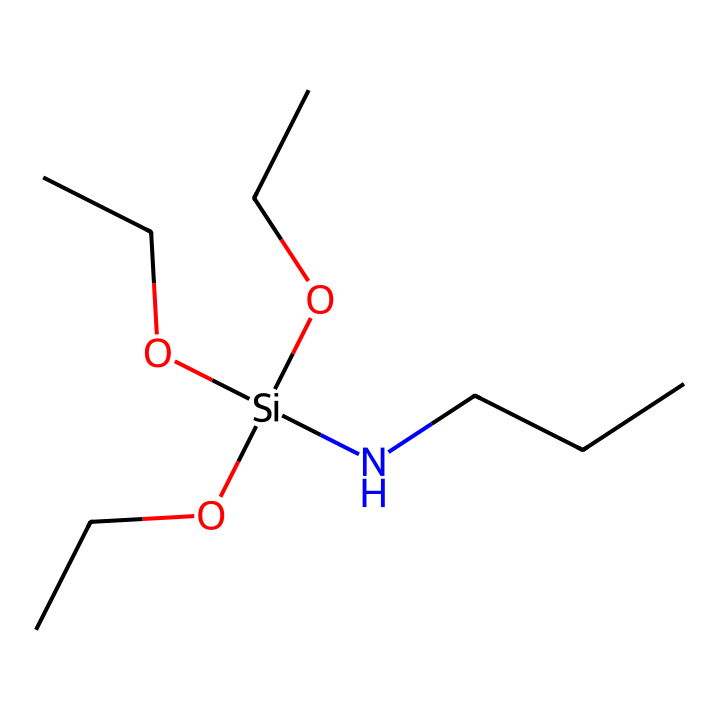What is the molecular formula of the represented chemical? The chemical structure shows three ethyl groups (OCC), one nitrogen atom (N), and one silicon atom (Si), along with three oxygen atoms (O). Counting all these components gives the molecular formula C9H21N1O3Si1.
Answer: C9H21N1O3Si1 How many ethyl groups are present in the structure? The structure features three OCC groups attached to the silicon atom. Each OCC stands for an ethyl group, hence there are three of them.
Answer: 3 What type of bonding is primarily present between silicon and oxygen in this structure? Silicon typically forms covalent bonds with oxygen due to its tetravalent nature and the electronic configuration that allows for sharing of electrons. The presence of silicon and oxygen indicates covalent bonding.
Answer: covalent What functional groups are present in this silane? The structure has three ether (OCC) functional groups and one amine group (N). The ether functionality comes from the ethyl groups connected to the oxygen atoms.
Answer: ether, amine Why is the nitrogen atom significant in this silane structure? The nitrogen atom contributes to the amine functionality, which can interact with other compounds and influence the adhesion properties of the silane coupling agents in materials, such as running shoe soles, enhancing performance and durability.
Answer: adhesion properties How many total atoms are there in the molecular structure? By counting all the atoms in the molecular formula (9 carbon, 21 hydrogen, 1 nitrogen, 3 oxygen, and 1 silicon), the total adds up to 35 atoms.
Answer: 35 